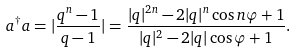<formula> <loc_0><loc_0><loc_500><loc_500>a ^ { \dagger } a = | \frac { q ^ { n } - 1 } { q - 1 } | = \frac { | q | ^ { 2 n } - 2 | q | ^ { n } \cos n \varphi + 1 } { | q | ^ { 2 } - 2 | q | \cos \varphi + 1 } .</formula> 